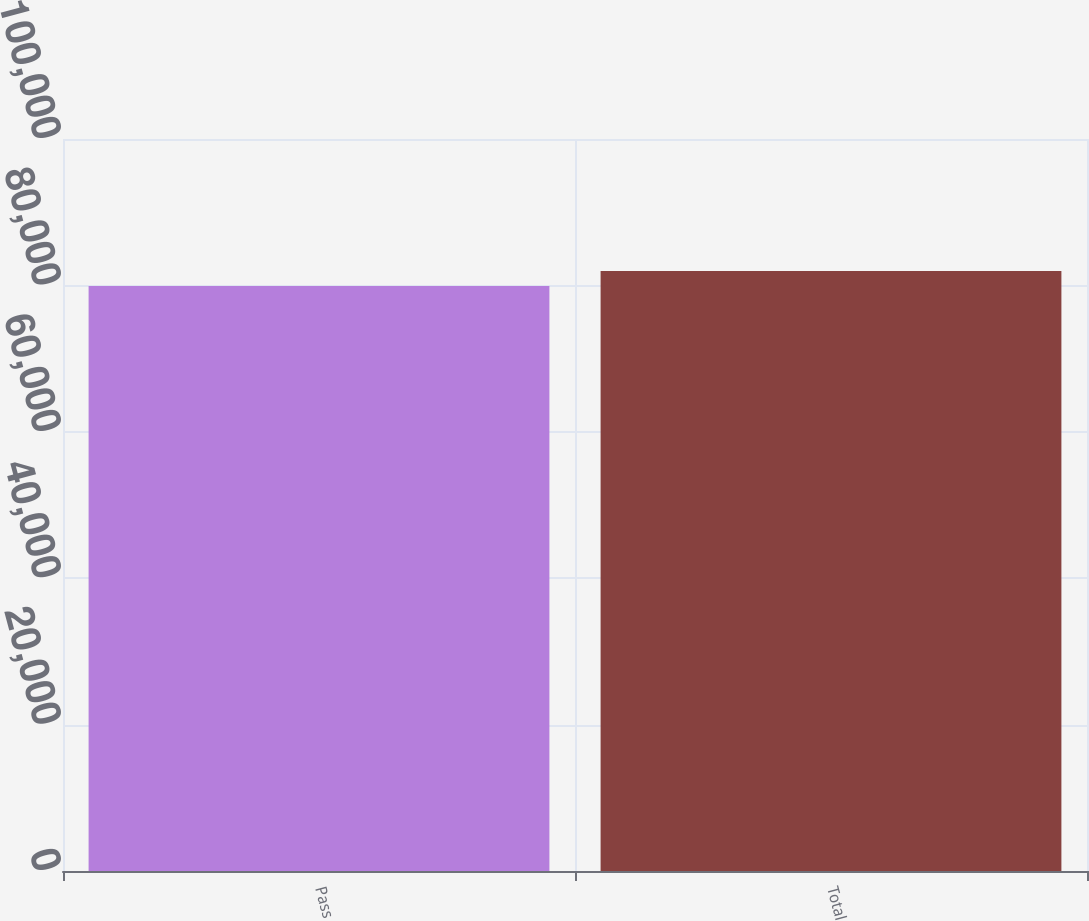Convert chart to OTSL. <chart><loc_0><loc_0><loc_500><loc_500><bar_chart><fcel>Pass<fcel>Total<nl><fcel>79901<fcel>81978<nl></chart> 